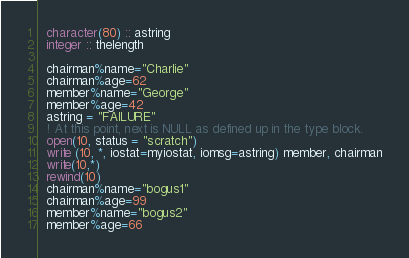<code> <loc_0><loc_0><loc_500><loc_500><_FORTRAN_>  character(80) :: astring
  integer :: thelength

  chairman%name="Charlie"
  chairman%age=62
  member%name="George"
  member%age=42
  astring = "FAILURE"
  ! At this point, next is NULL as defined up in the type block.
  open(10, status = "scratch")
  write (10, *, iostat=myiostat, iomsg=astring) member, chairman
  write(10,*)
  rewind(10)
  chairman%name="bogus1"
  chairman%age=99
  member%name="bogus2"
  member%age=66</code> 